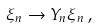Convert formula to latex. <formula><loc_0><loc_0><loc_500><loc_500>\xi _ { n } \to Y _ { n } \xi _ { n } \, ,</formula> 